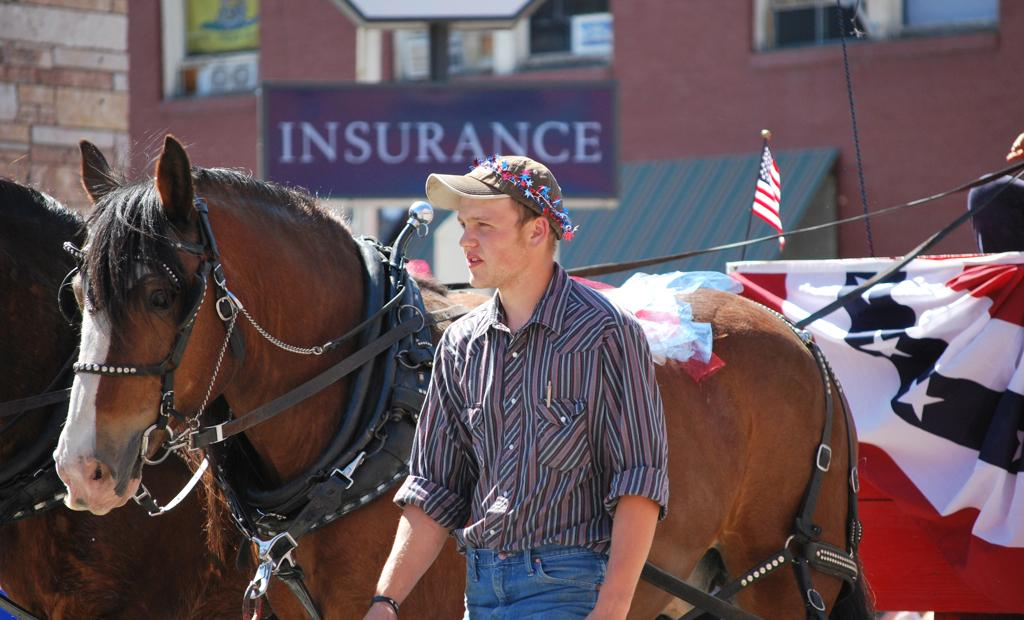Who is present in the image? There is a man in the image. What is located behind the man? There is a horse cart behind the man. What type of advertisement is visible in the image? There is a hoarding in the image. What is the flag associated with in the image? The flag is present in the image. What type of structure can be seen in the image? There is a building in the image. Can you see a basin filled with snow near the lake in the image? There is no basin, snow, or lake present in the image. 